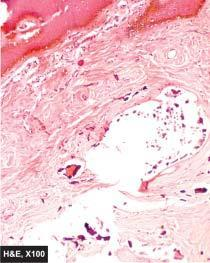what shows masses or nodules of calcium salt surrounded by foreign body giant cells?
Answer the question using a single word or phrase. Subcutaneous tissue 